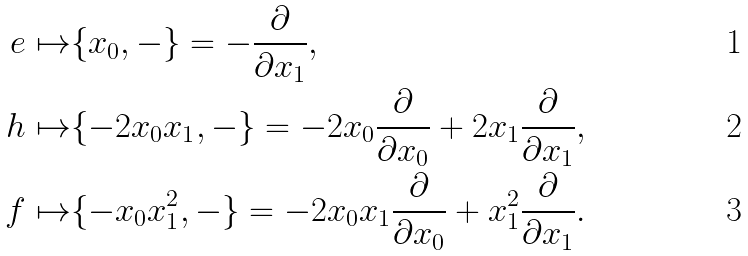Convert formula to latex. <formula><loc_0><loc_0><loc_500><loc_500>e \mapsto & \{ x _ { 0 } , - \} = - \frac { \partial } { \partial x _ { 1 } } , \\ h \mapsto & \{ - 2 x _ { 0 } x _ { 1 } , - \} = - 2 x _ { 0 } \frac { \partial } { \partial x _ { 0 } } + 2 x _ { 1 } \frac { \partial } { \partial x _ { 1 } } , \\ f \mapsto & \{ - x _ { 0 } x _ { 1 } ^ { 2 } , - \} = - 2 x _ { 0 } x _ { 1 } \frac { \partial } { \partial x _ { 0 } } + x _ { 1 } ^ { 2 } \frac { \partial } { \partial x _ { 1 } } .</formula> 